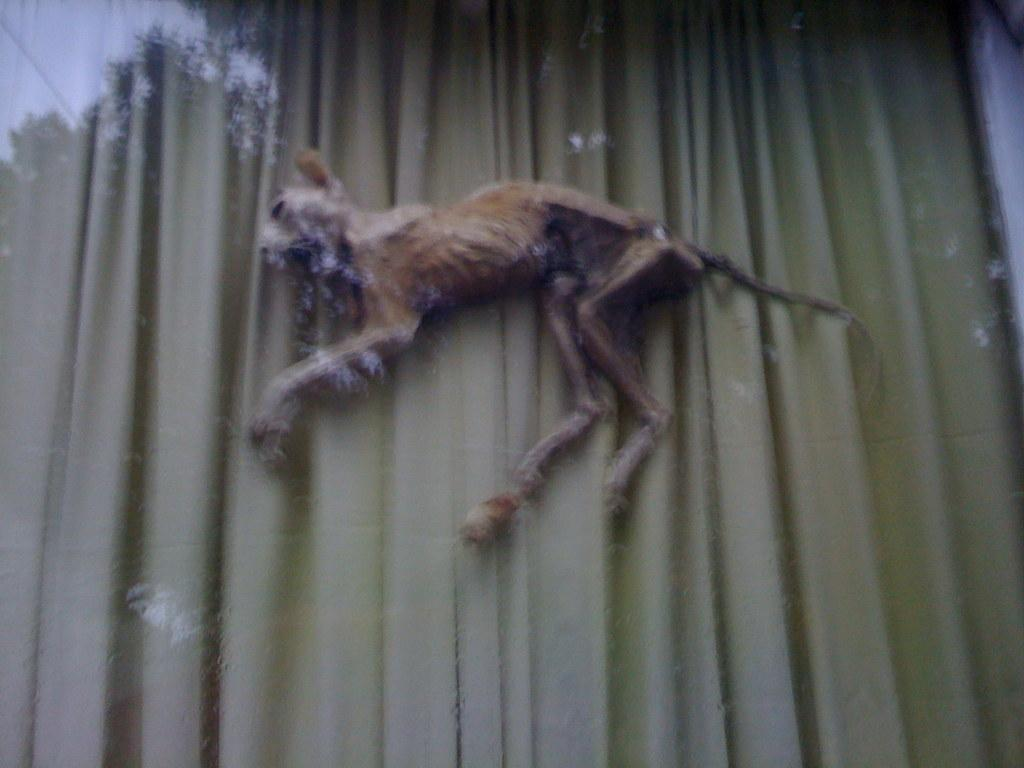What type of animal is present in the image? There is an animal in the image, but the specific type cannot be determined from the provided facts. What can be seen in the background of the image? There is a curtain in the background of the image. What type of flower is being held by the stranger in the image? There is no stranger present in the image, and therefore no flower being held by a stranger. 